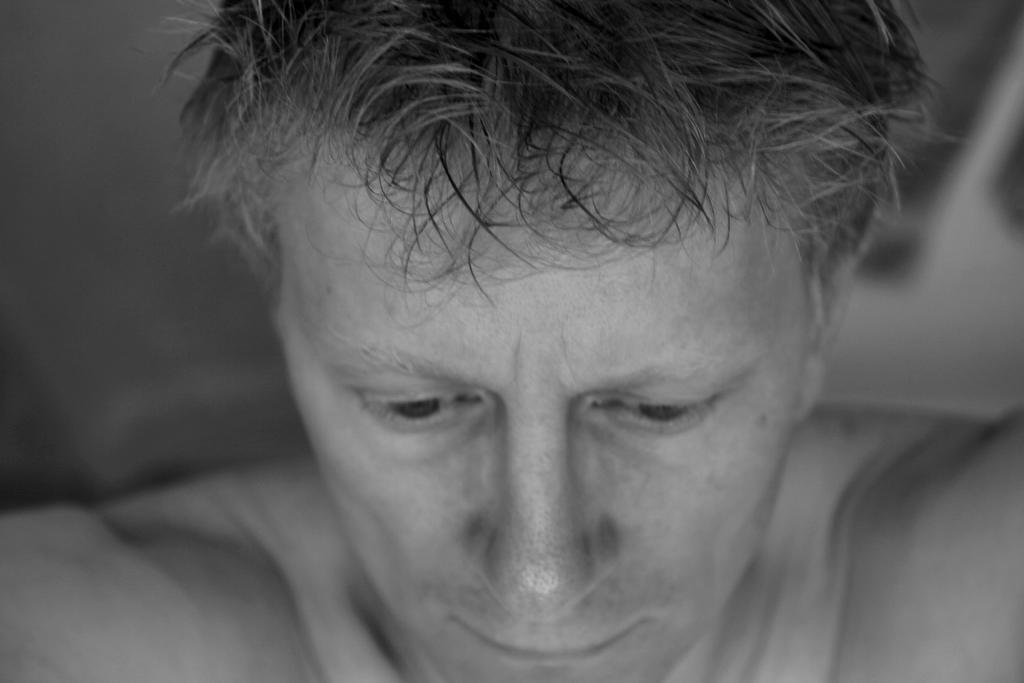Who is present in the image? There is a man in the image. Can you describe the background of the image? The background of the image is blurry. What type of meat is being prepared in the image? There is no meat present in the image. How many lizards can be seen in the image? There are no lizards present in the image. 